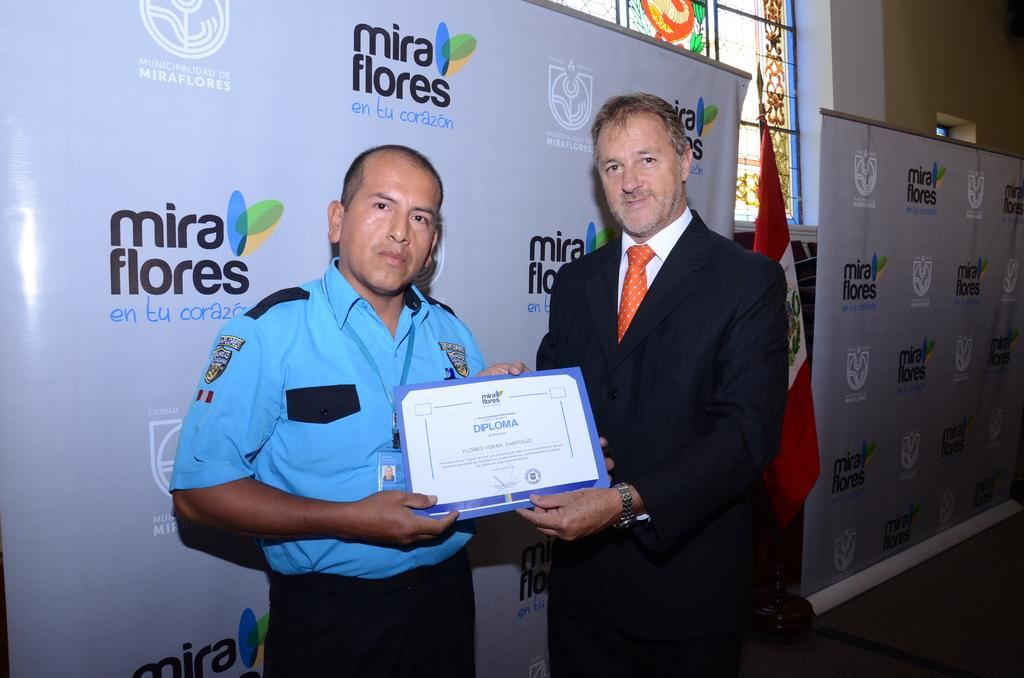How many people are present in the image? There are two people in the image. What are the people doing in the image? The people are holding an object. What can be seen on the board in the image? There is written text on a board in the image. What is the flag associated with in the image? The flag is present in the image. What architectural feature is visible in the image? There is a window in the image. What can be seen through the window in the image? There is an antique painting visible through the window. How many beetles can be seen crawling on the flag in the image? There are no beetles present in the image, and therefore no such activity can be observed. What type of ducks are swimming in the pond visible through the window in the image? There is no pond visible through the window in the image, only an antique painting. 